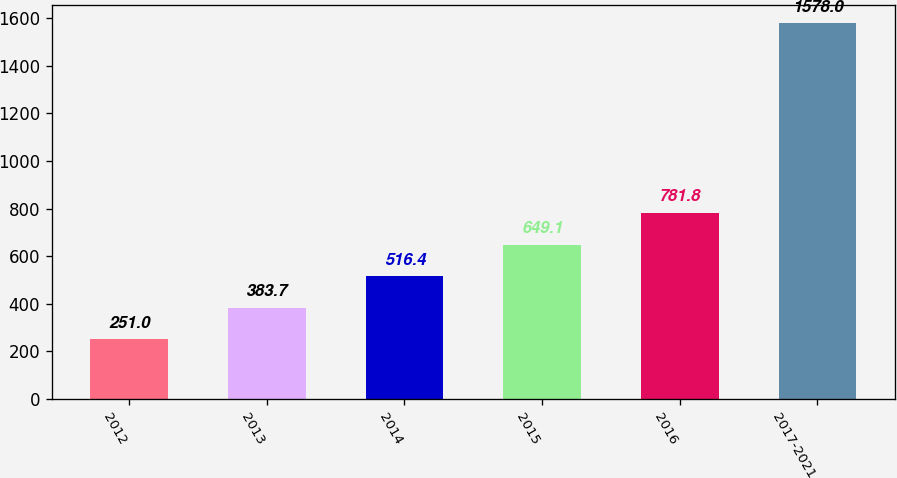<chart> <loc_0><loc_0><loc_500><loc_500><bar_chart><fcel>2012<fcel>2013<fcel>2014<fcel>2015<fcel>2016<fcel>2017-2021<nl><fcel>251<fcel>383.7<fcel>516.4<fcel>649.1<fcel>781.8<fcel>1578<nl></chart> 